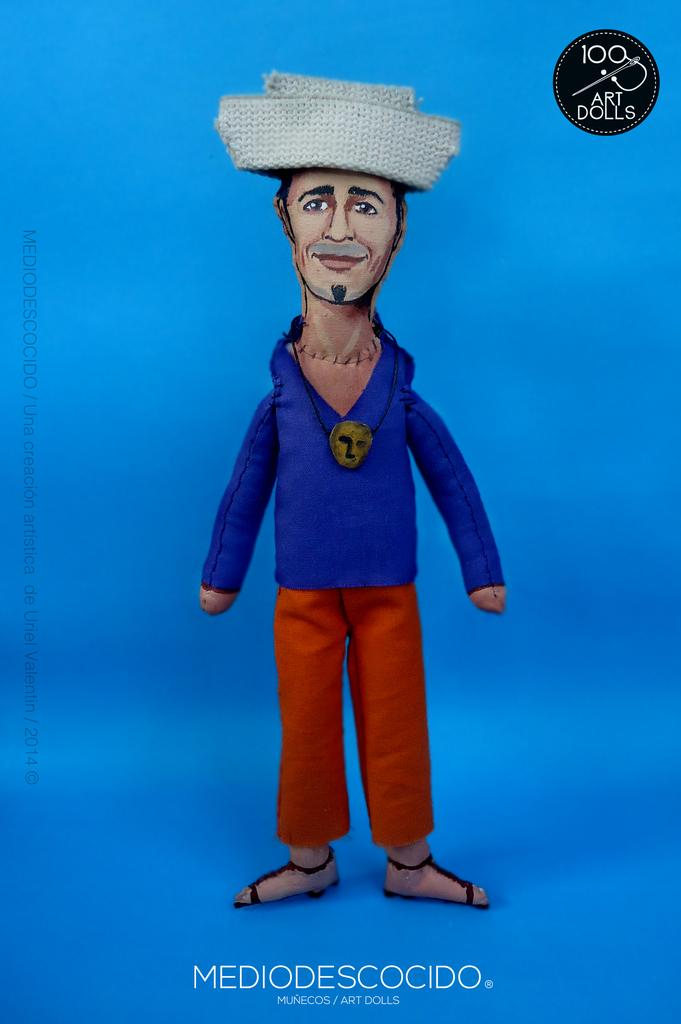What type of character is in the picture? There is an animated person in the picture. What is the animated person wearing on their head? The animated person is wearing a hat. What type of clothing is the animated person wearing on their upper body? The animated person is wearing a t-shirt. What type of clothing is the animated person wearing on their lower body? The animated person is wearing trousers. What type of footwear is the animated person wearing? The animated person is wearing sandals. Is there any additional information or marking on the image? Yes, there is a watermark at the bottom of the image. How many toes are visible on the page in the image? There are no visible toes or pages in the image; it features an animated person wearing sandals. 